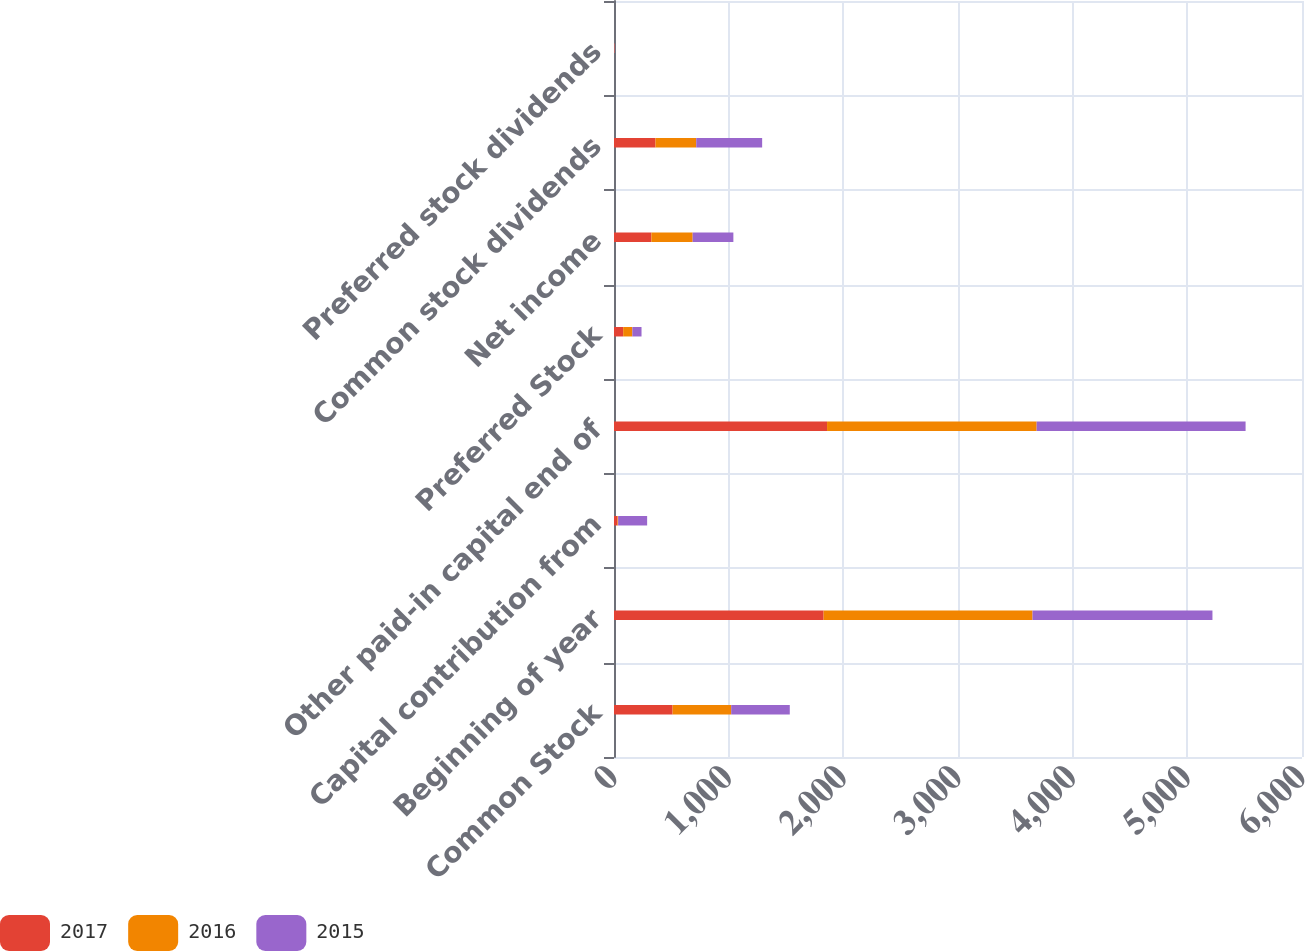Convert chart to OTSL. <chart><loc_0><loc_0><loc_500><loc_500><stacked_bar_chart><ecel><fcel>Common Stock<fcel>Beginning of year<fcel>Capital contribution from<fcel>Other paid-in capital end of<fcel>Preferred Stock<fcel>Net income<fcel>Common stock dividends<fcel>Preferred stock dividends<nl><fcel>2017<fcel>511<fcel>1828<fcel>30<fcel>1858<fcel>80<fcel>326<fcel>362<fcel>3<nl><fcel>2016<fcel>511<fcel>1822<fcel>6<fcel>1828<fcel>80<fcel>360<fcel>355<fcel>3<nl><fcel>2015<fcel>511<fcel>1569<fcel>253<fcel>1822<fcel>80<fcel>355<fcel>575<fcel>3<nl></chart> 